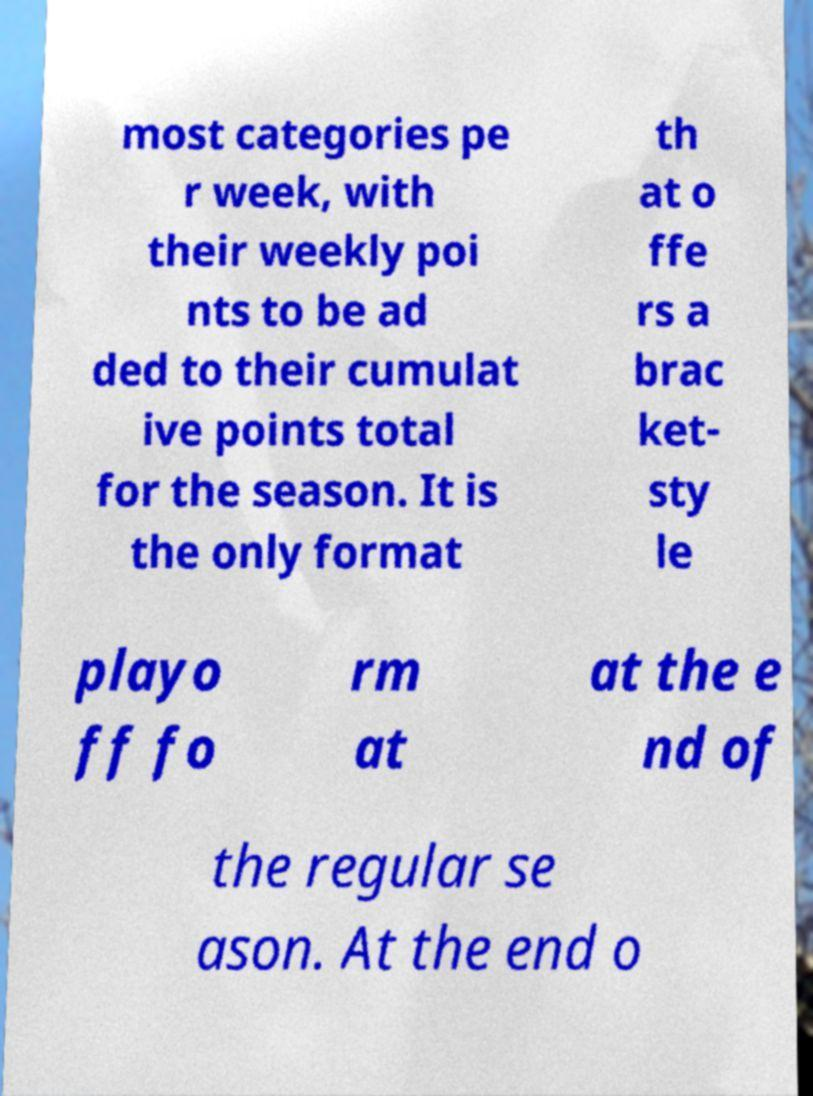Please identify and transcribe the text found in this image. most categories pe r week, with their weekly poi nts to be ad ded to their cumulat ive points total for the season. It is the only format th at o ffe rs a brac ket- sty le playo ff fo rm at at the e nd of the regular se ason. At the end o 